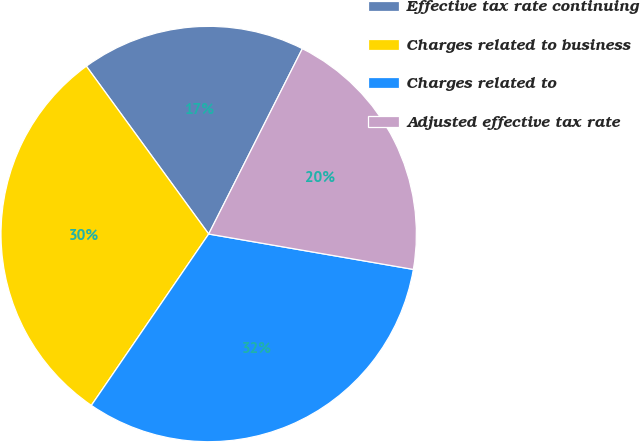Convert chart to OTSL. <chart><loc_0><loc_0><loc_500><loc_500><pie_chart><fcel>Effective tax rate continuing<fcel>Charges related to business<fcel>Charges related to<fcel>Adjusted effective tax rate<nl><fcel>17.47%<fcel>30.42%<fcel>31.83%<fcel>20.28%<nl></chart> 